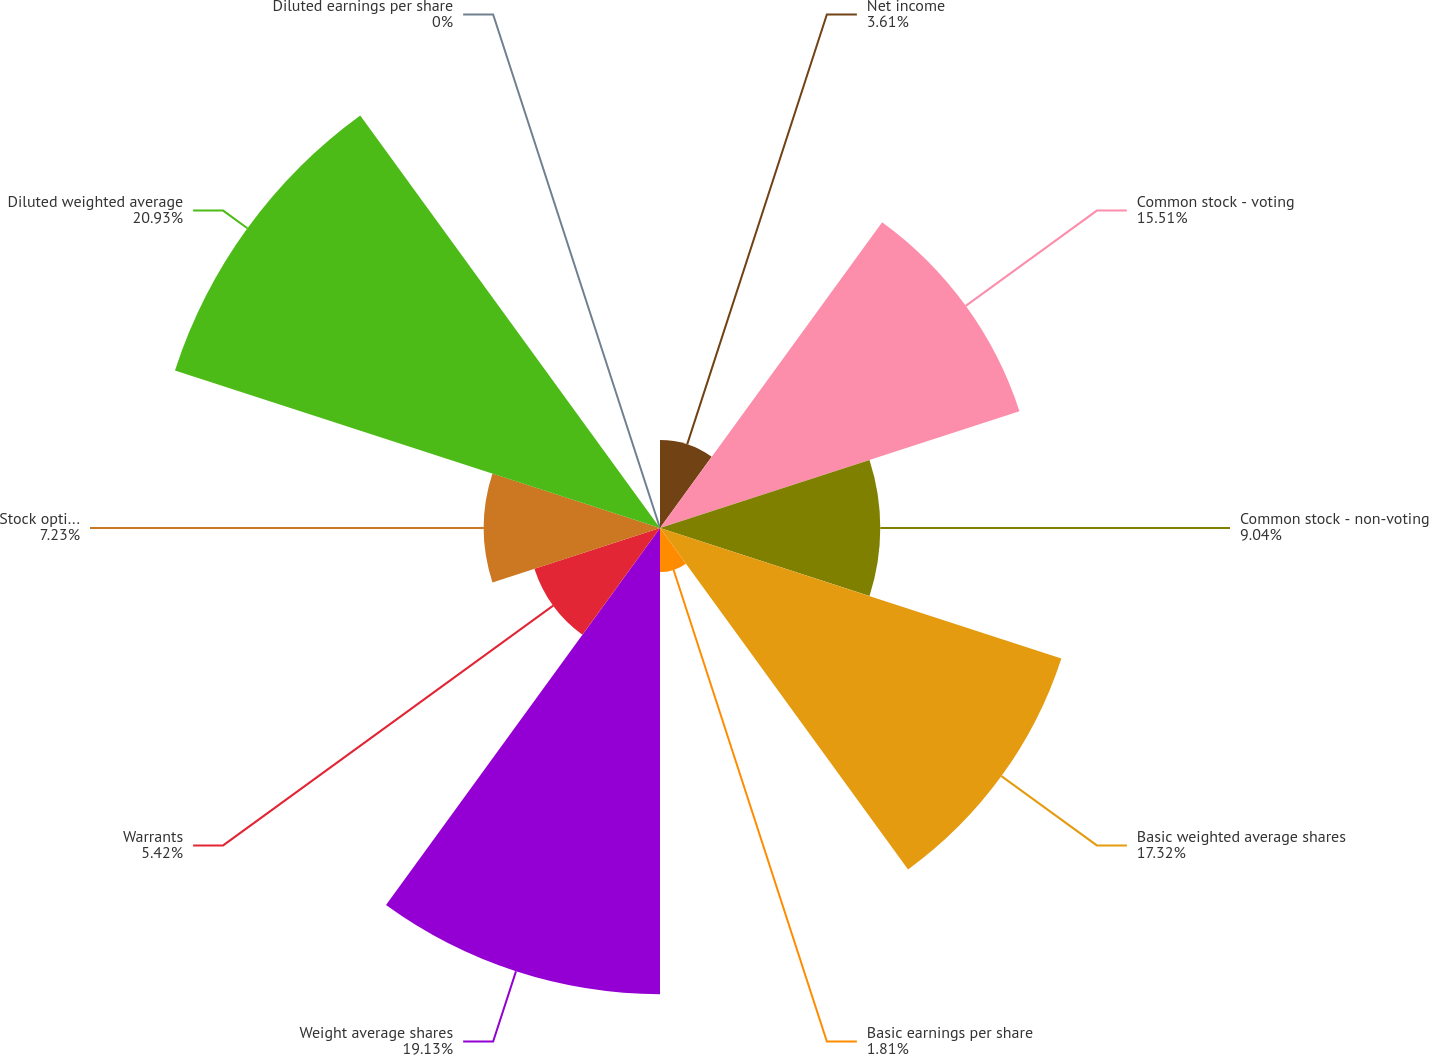<chart> <loc_0><loc_0><loc_500><loc_500><pie_chart><fcel>Net income<fcel>Common stock - voting<fcel>Common stock - non-voting<fcel>Basic weighted average shares<fcel>Basic earnings per share<fcel>Weight average shares<fcel>Warrants<fcel>Stock options and restricted<fcel>Diluted weighted average<fcel>Diluted earnings per share<nl><fcel>3.61%<fcel>15.51%<fcel>9.04%<fcel>17.32%<fcel>1.81%<fcel>19.13%<fcel>5.42%<fcel>7.23%<fcel>20.93%<fcel>0.0%<nl></chart> 